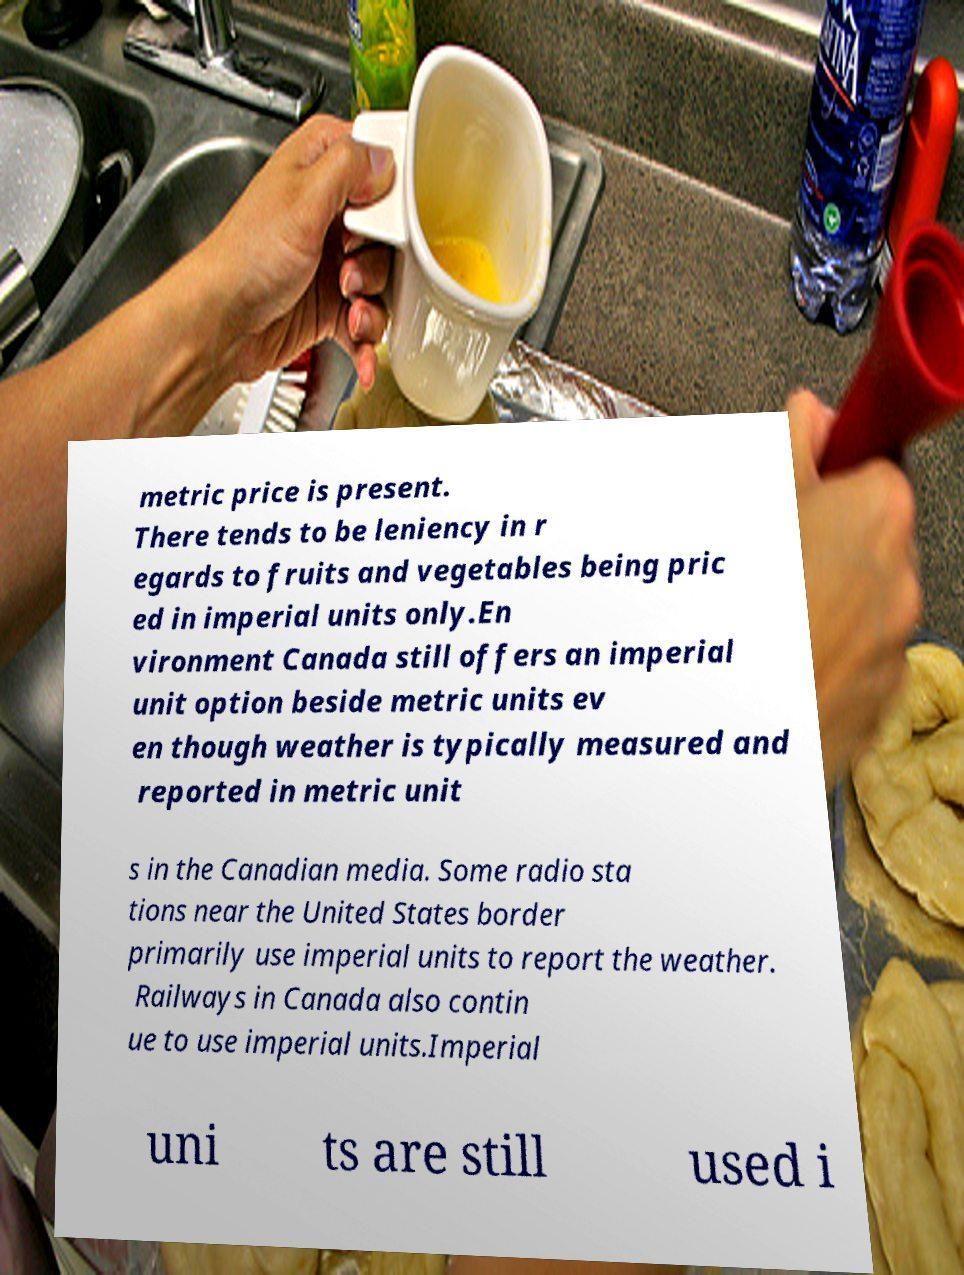Please identify and transcribe the text found in this image. metric price is present. There tends to be leniency in r egards to fruits and vegetables being pric ed in imperial units only.En vironment Canada still offers an imperial unit option beside metric units ev en though weather is typically measured and reported in metric unit s in the Canadian media. Some radio sta tions near the United States border primarily use imperial units to report the weather. Railways in Canada also contin ue to use imperial units.Imperial uni ts are still used i 